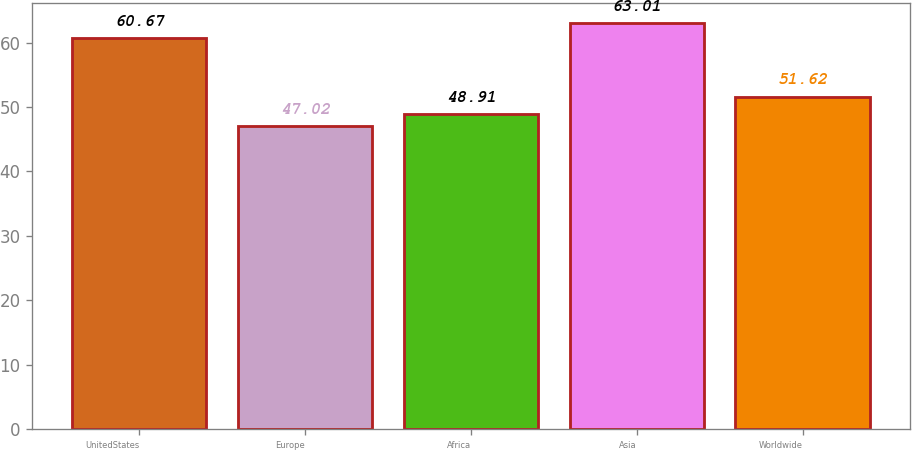<chart> <loc_0><loc_0><loc_500><loc_500><bar_chart><fcel>UnitedStates<fcel>Europe<fcel>Africa<fcel>Asia<fcel>Worldwide<nl><fcel>60.67<fcel>47.02<fcel>48.91<fcel>63.01<fcel>51.62<nl></chart> 